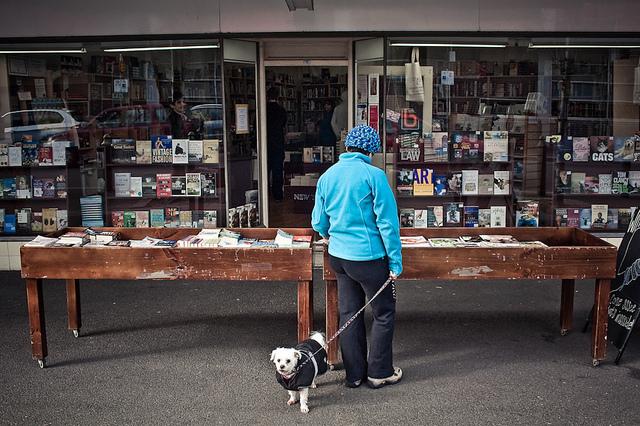What is the person looking at?
Give a very brief answer. Books. Why does the dog have the black clothing on?
Give a very brief answer. To stay warm. Is the dog going to run away?
Concise answer only. No. 